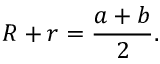<formula> <loc_0><loc_0><loc_500><loc_500>R + r = { \frac { a + b } { 2 } } .</formula> 